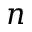Convert formula to latex. <formula><loc_0><loc_0><loc_500><loc_500>n</formula> 